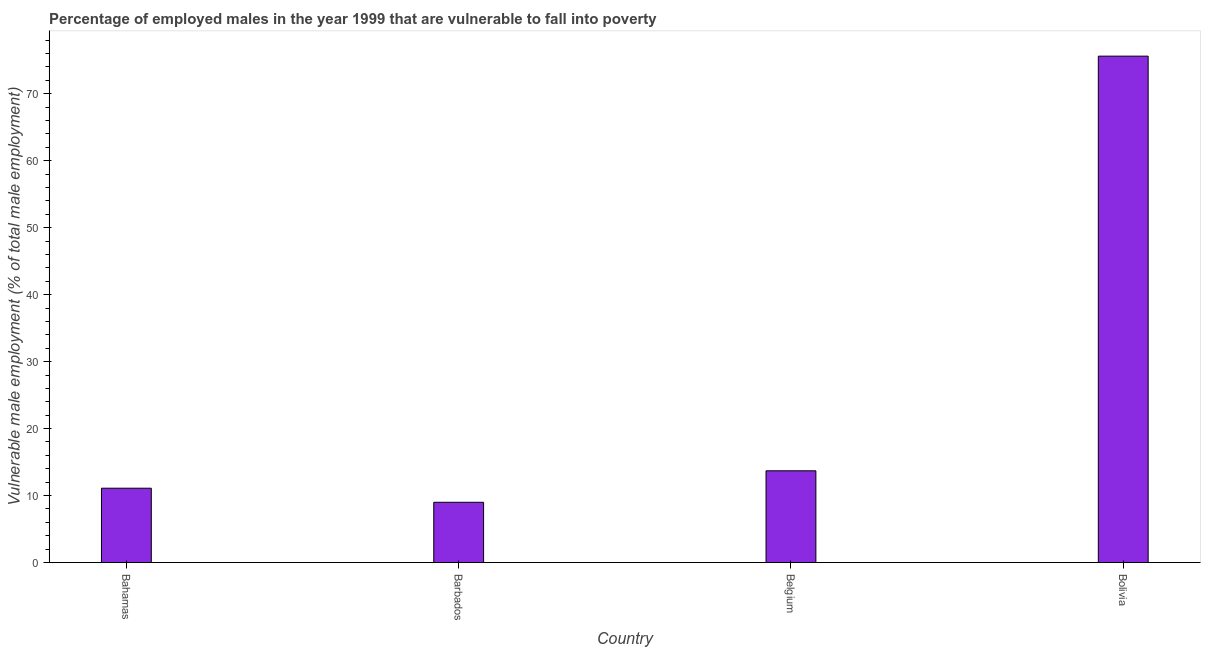Does the graph contain any zero values?
Make the answer very short. No. What is the title of the graph?
Provide a succinct answer. Percentage of employed males in the year 1999 that are vulnerable to fall into poverty. What is the label or title of the Y-axis?
Your response must be concise. Vulnerable male employment (% of total male employment). What is the percentage of employed males who are vulnerable to fall into poverty in Belgium?
Your answer should be very brief. 13.7. Across all countries, what is the maximum percentage of employed males who are vulnerable to fall into poverty?
Your answer should be very brief. 75.6. Across all countries, what is the minimum percentage of employed males who are vulnerable to fall into poverty?
Keep it short and to the point. 9. In which country was the percentage of employed males who are vulnerable to fall into poverty maximum?
Provide a succinct answer. Bolivia. In which country was the percentage of employed males who are vulnerable to fall into poverty minimum?
Provide a succinct answer. Barbados. What is the sum of the percentage of employed males who are vulnerable to fall into poverty?
Offer a terse response. 109.4. What is the average percentage of employed males who are vulnerable to fall into poverty per country?
Offer a terse response. 27.35. What is the median percentage of employed males who are vulnerable to fall into poverty?
Provide a short and direct response. 12.4. In how many countries, is the percentage of employed males who are vulnerable to fall into poverty greater than 10 %?
Provide a succinct answer. 3. What is the ratio of the percentage of employed males who are vulnerable to fall into poverty in Bahamas to that in Belgium?
Give a very brief answer. 0.81. Is the difference between the percentage of employed males who are vulnerable to fall into poverty in Bahamas and Belgium greater than the difference between any two countries?
Keep it short and to the point. No. What is the difference between the highest and the second highest percentage of employed males who are vulnerable to fall into poverty?
Your answer should be compact. 61.9. What is the difference between the highest and the lowest percentage of employed males who are vulnerable to fall into poverty?
Offer a very short reply. 66.6. Are all the bars in the graph horizontal?
Keep it short and to the point. No. What is the difference between two consecutive major ticks on the Y-axis?
Give a very brief answer. 10. Are the values on the major ticks of Y-axis written in scientific E-notation?
Offer a terse response. No. What is the Vulnerable male employment (% of total male employment) in Bahamas?
Ensure brevity in your answer.  11.1. What is the Vulnerable male employment (% of total male employment) in Belgium?
Your answer should be compact. 13.7. What is the Vulnerable male employment (% of total male employment) in Bolivia?
Provide a succinct answer. 75.6. What is the difference between the Vulnerable male employment (% of total male employment) in Bahamas and Bolivia?
Offer a terse response. -64.5. What is the difference between the Vulnerable male employment (% of total male employment) in Barbados and Bolivia?
Ensure brevity in your answer.  -66.6. What is the difference between the Vulnerable male employment (% of total male employment) in Belgium and Bolivia?
Ensure brevity in your answer.  -61.9. What is the ratio of the Vulnerable male employment (% of total male employment) in Bahamas to that in Barbados?
Give a very brief answer. 1.23. What is the ratio of the Vulnerable male employment (% of total male employment) in Bahamas to that in Belgium?
Provide a short and direct response. 0.81. What is the ratio of the Vulnerable male employment (% of total male employment) in Bahamas to that in Bolivia?
Ensure brevity in your answer.  0.15. What is the ratio of the Vulnerable male employment (% of total male employment) in Barbados to that in Belgium?
Your answer should be very brief. 0.66. What is the ratio of the Vulnerable male employment (% of total male employment) in Barbados to that in Bolivia?
Give a very brief answer. 0.12. What is the ratio of the Vulnerable male employment (% of total male employment) in Belgium to that in Bolivia?
Your response must be concise. 0.18. 